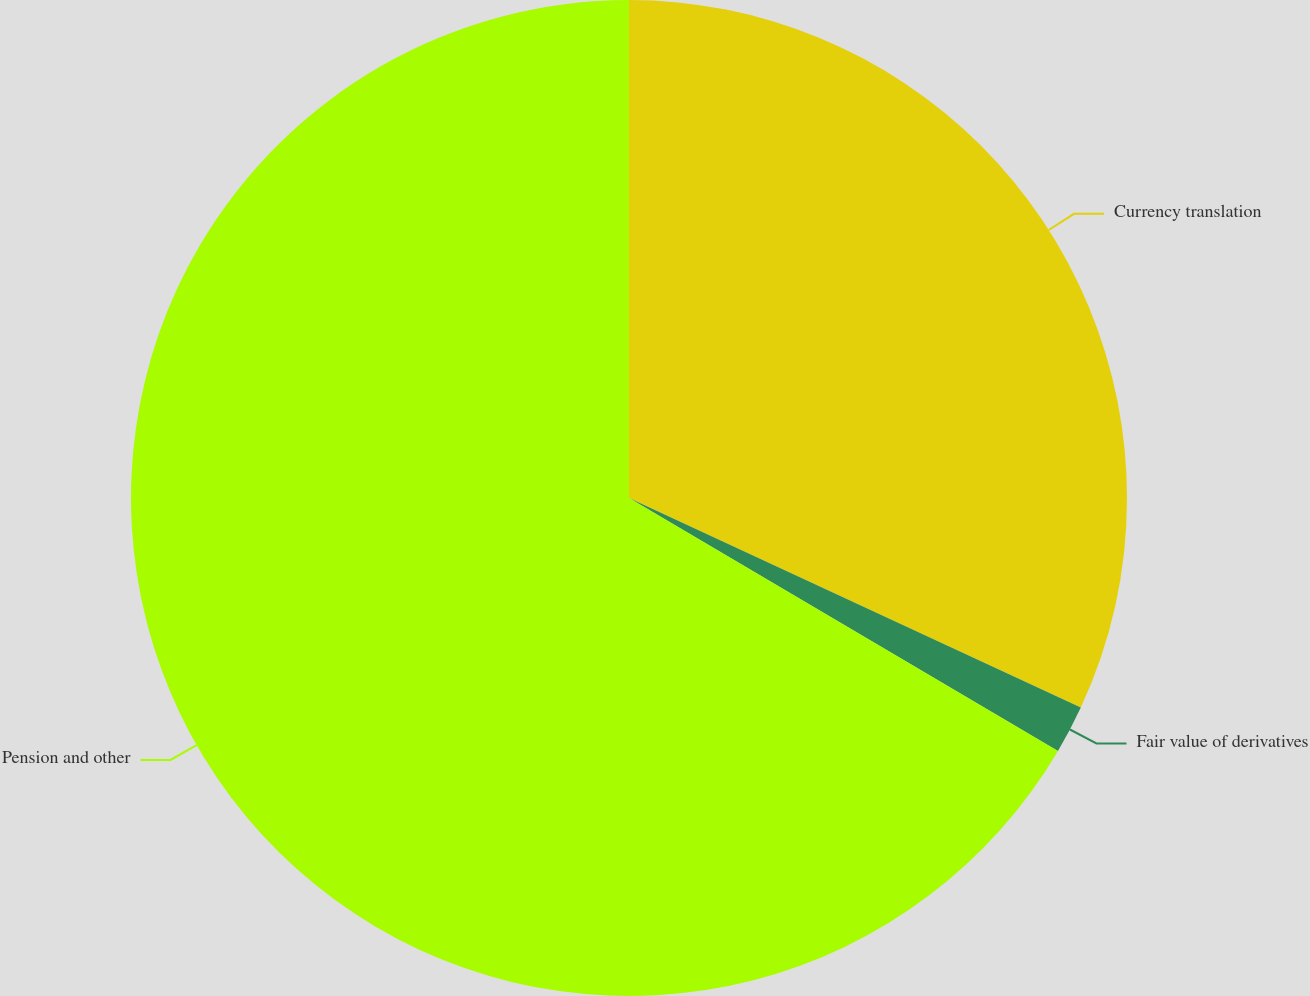<chart> <loc_0><loc_0><loc_500><loc_500><pie_chart><fcel>Currency translation<fcel>Fair value of derivatives<fcel>Pension and other<nl><fcel>31.91%<fcel>1.57%<fcel>66.52%<nl></chart> 